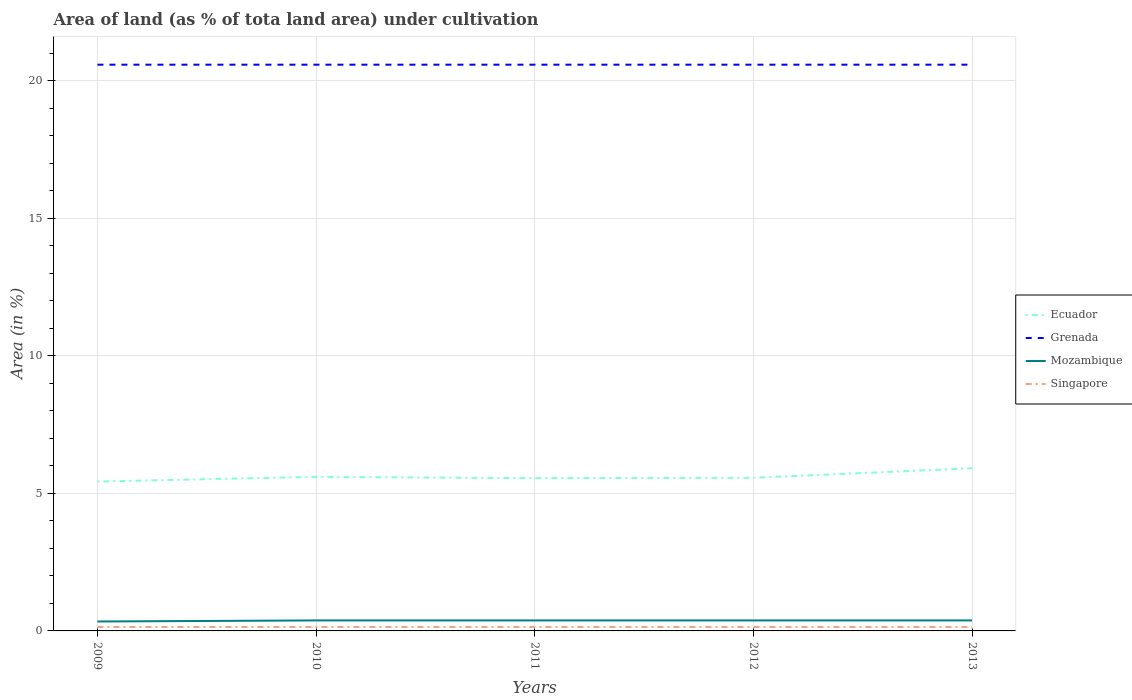How many different coloured lines are there?
Ensure brevity in your answer.  4. Does the line corresponding to Mozambique intersect with the line corresponding to Ecuador?
Offer a very short reply. No. Is the number of lines equal to the number of legend labels?
Your answer should be very brief. Yes. Across all years, what is the maximum percentage of land under cultivation in Grenada?
Offer a terse response. 20.59. What is the difference between the highest and the second highest percentage of land under cultivation in Singapore?
Your response must be concise. 0. What is the difference between the highest and the lowest percentage of land under cultivation in Mozambique?
Keep it short and to the point. 4. How many years are there in the graph?
Your response must be concise. 5. How many legend labels are there?
Keep it short and to the point. 4. What is the title of the graph?
Provide a succinct answer. Area of land (as % of tota land area) under cultivation. Does "Aruba" appear as one of the legend labels in the graph?
Give a very brief answer. No. What is the label or title of the Y-axis?
Your answer should be compact. Area (in %). What is the Area (in %) in Ecuador in 2009?
Your answer should be very brief. 5.43. What is the Area (in %) in Grenada in 2009?
Your answer should be very brief. 20.59. What is the Area (in %) of Mozambique in 2009?
Your answer should be very brief. 0.34. What is the Area (in %) in Singapore in 2009?
Your answer should be compact. 0.14. What is the Area (in %) in Ecuador in 2010?
Your response must be concise. 5.6. What is the Area (in %) of Grenada in 2010?
Make the answer very short. 20.59. What is the Area (in %) in Mozambique in 2010?
Your answer should be very brief. 0.38. What is the Area (in %) in Singapore in 2010?
Your answer should be compact. 0.14. What is the Area (in %) in Ecuador in 2011?
Give a very brief answer. 5.55. What is the Area (in %) in Grenada in 2011?
Your answer should be very brief. 20.59. What is the Area (in %) in Mozambique in 2011?
Offer a terse response. 0.38. What is the Area (in %) in Singapore in 2011?
Offer a terse response. 0.14. What is the Area (in %) in Ecuador in 2012?
Provide a succinct answer. 5.57. What is the Area (in %) of Grenada in 2012?
Offer a terse response. 20.59. What is the Area (in %) in Mozambique in 2012?
Provide a succinct answer. 0.38. What is the Area (in %) of Singapore in 2012?
Keep it short and to the point. 0.14. What is the Area (in %) in Ecuador in 2013?
Provide a succinct answer. 5.91. What is the Area (in %) in Grenada in 2013?
Provide a short and direct response. 20.59. What is the Area (in %) in Mozambique in 2013?
Provide a short and direct response. 0.38. What is the Area (in %) in Singapore in 2013?
Your answer should be very brief. 0.14. Across all years, what is the maximum Area (in %) in Ecuador?
Ensure brevity in your answer.  5.91. Across all years, what is the maximum Area (in %) in Grenada?
Make the answer very short. 20.59. Across all years, what is the maximum Area (in %) in Mozambique?
Your response must be concise. 0.38. Across all years, what is the maximum Area (in %) of Singapore?
Offer a terse response. 0.14. Across all years, what is the minimum Area (in %) in Ecuador?
Give a very brief answer. 5.43. Across all years, what is the minimum Area (in %) in Grenada?
Give a very brief answer. 20.59. Across all years, what is the minimum Area (in %) of Mozambique?
Offer a terse response. 0.34. Across all years, what is the minimum Area (in %) in Singapore?
Your response must be concise. 0.14. What is the total Area (in %) in Ecuador in the graph?
Provide a short and direct response. 28.07. What is the total Area (in %) in Grenada in the graph?
Make the answer very short. 102.94. What is the total Area (in %) in Mozambique in the graph?
Offer a terse response. 1.87. What is the total Area (in %) in Singapore in the graph?
Ensure brevity in your answer.  0.71. What is the difference between the Area (in %) in Ecuador in 2009 and that in 2010?
Ensure brevity in your answer.  -0.17. What is the difference between the Area (in %) in Mozambique in 2009 and that in 2010?
Make the answer very short. -0.04. What is the difference between the Area (in %) in Singapore in 2009 and that in 2010?
Give a very brief answer. 0. What is the difference between the Area (in %) of Ecuador in 2009 and that in 2011?
Your answer should be very brief. -0.12. What is the difference between the Area (in %) in Grenada in 2009 and that in 2011?
Provide a succinct answer. 0. What is the difference between the Area (in %) in Mozambique in 2009 and that in 2011?
Your response must be concise. -0.04. What is the difference between the Area (in %) in Singapore in 2009 and that in 2011?
Your answer should be very brief. 0. What is the difference between the Area (in %) of Ecuador in 2009 and that in 2012?
Make the answer very short. -0.14. What is the difference between the Area (in %) in Mozambique in 2009 and that in 2012?
Provide a short and direct response. -0.04. What is the difference between the Area (in %) of Singapore in 2009 and that in 2012?
Ensure brevity in your answer.  0. What is the difference between the Area (in %) of Ecuador in 2009 and that in 2013?
Offer a terse response. -0.48. What is the difference between the Area (in %) of Mozambique in 2009 and that in 2013?
Provide a short and direct response. -0.04. What is the difference between the Area (in %) of Singapore in 2009 and that in 2013?
Give a very brief answer. 0. What is the difference between the Area (in %) of Ecuador in 2010 and that in 2011?
Your answer should be very brief. 0.05. What is the difference between the Area (in %) in Grenada in 2010 and that in 2011?
Offer a terse response. 0. What is the difference between the Area (in %) in Mozambique in 2010 and that in 2011?
Offer a very short reply. 0. What is the difference between the Area (in %) of Ecuador in 2010 and that in 2012?
Give a very brief answer. 0.03. What is the difference between the Area (in %) of Mozambique in 2010 and that in 2012?
Give a very brief answer. 0. What is the difference between the Area (in %) in Singapore in 2010 and that in 2012?
Your answer should be compact. 0. What is the difference between the Area (in %) of Ecuador in 2010 and that in 2013?
Provide a short and direct response. -0.31. What is the difference between the Area (in %) of Singapore in 2010 and that in 2013?
Your answer should be compact. 0. What is the difference between the Area (in %) of Ecuador in 2011 and that in 2012?
Make the answer very short. -0.01. What is the difference between the Area (in %) in Grenada in 2011 and that in 2012?
Your answer should be compact. 0. What is the difference between the Area (in %) of Ecuador in 2011 and that in 2013?
Offer a very short reply. -0.36. What is the difference between the Area (in %) in Mozambique in 2011 and that in 2013?
Provide a short and direct response. 0. What is the difference between the Area (in %) of Singapore in 2011 and that in 2013?
Offer a very short reply. 0. What is the difference between the Area (in %) of Ecuador in 2012 and that in 2013?
Offer a very short reply. -0.35. What is the difference between the Area (in %) of Grenada in 2012 and that in 2013?
Give a very brief answer. 0. What is the difference between the Area (in %) of Singapore in 2012 and that in 2013?
Provide a short and direct response. 0. What is the difference between the Area (in %) in Ecuador in 2009 and the Area (in %) in Grenada in 2010?
Your response must be concise. -15.16. What is the difference between the Area (in %) in Ecuador in 2009 and the Area (in %) in Mozambique in 2010?
Make the answer very short. 5.05. What is the difference between the Area (in %) of Ecuador in 2009 and the Area (in %) of Singapore in 2010?
Keep it short and to the point. 5.29. What is the difference between the Area (in %) of Grenada in 2009 and the Area (in %) of Mozambique in 2010?
Offer a very short reply. 20.21. What is the difference between the Area (in %) of Grenada in 2009 and the Area (in %) of Singapore in 2010?
Give a very brief answer. 20.45. What is the difference between the Area (in %) in Mozambique in 2009 and the Area (in %) in Singapore in 2010?
Your answer should be very brief. 0.2. What is the difference between the Area (in %) in Ecuador in 2009 and the Area (in %) in Grenada in 2011?
Offer a very short reply. -15.16. What is the difference between the Area (in %) in Ecuador in 2009 and the Area (in %) in Mozambique in 2011?
Keep it short and to the point. 5.05. What is the difference between the Area (in %) in Ecuador in 2009 and the Area (in %) in Singapore in 2011?
Your answer should be very brief. 5.29. What is the difference between the Area (in %) of Grenada in 2009 and the Area (in %) of Mozambique in 2011?
Your answer should be compact. 20.21. What is the difference between the Area (in %) of Grenada in 2009 and the Area (in %) of Singapore in 2011?
Your response must be concise. 20.45. What is the difference between the Area (in %) in Mozambique in 2009 and the Area (in %) in Singapore in 2011?
Provide a succinct answer. 0.2. What is the difference between the Area (in %) of Ecuador in 2009 and the Area (in %) of Grenada in 2012?
Ensure brevity in your answer.  -15.16. What is the difference between the Area (in %) of Ecuador in 2009 and the Area (in %) of Mozambique in 2012?
Give a very brief answer. 5.05. What is the difference between the Area (in %) of Ecuador in 2009 and the Area (in %) of Singapore in 2012?
Your answer should be very brief. 5.29. What is the difference between the Area (in %) in Grenada in 2009 and the Area (in %) in Mozambique in 2012?
Your answer should be compact. 20.21. What is the difference between the Area (in %) in Grenada in 2009 and the Area (in %) in Singapore in 2012?
Provide a short and direct response. 20.45. What is the difference between the Area (in %) of Mozambique in 2009 and the Area (in %) of Singapore in 2012?
Ensure brevity in your answer.  0.2. What is the difference between the Area (in %) in Ecuador in 2009 and the Area (in %) in Grenada in 2013?
Make the answer very short. -15.16. What is the difference between the Area (in %) in Ecuador in 2009 and the Area (in %) in Mozambique in 2013?
Your answer should be very brief. 5.05. What is the difference between the Area (in %) in Ecuador in 2009 and the Area (in %) in Singapore in 2013?
Provide a short and direct response. 5.29. What is the difference between the Area (in %) of Grenada in 2009 and the Area (in %) of Mozambique in 2013?
Provide a succinct answer. 20.21. What is the difference between the Area (in %) in Grenada in 2009 and the Area (in %) in Singapore in 2013?
Provide a short and direct response. 20.45. What is the difference between the Area (in %) in Mozambique in 2009 and the Area (in %) in Singapore in 2013?
Give a very brief answer. 0.2. What is the difference between the Area (in %) of Ecuador in 2010 and the Area (in %) of Grenada in 2011?
Your response must be concise. -14.99. What is the difference between the Area (in %) in Ecuador in 2010 and the Area (in %) in Mozambique in 2011?
Provide a short and direct response. 5.22. What is the difference between the Area (in %) in Ecuador in 2010 and the Area (in %) in Singapore in 2011?
Your answer should be very brief. 5.46. What is the difference between the Area (in %) of Grenada in 2010 and the Area (in %) of Mozambique in 2011?
Offer a very short reply. 20.21. What is the difference between the Area (in %) of Grenada in 2010 and the Area (in %) of Singapore in 2011?
Keep it short and to the point. 20.45. What is the difference between the Area (in %) in Mozambique in 2010 and the Area (in %) in Singapore in 2011?
Make the answer very short. 0.24. What is the difference between the Area (in %) of Ecuador in 2010 and the Area (in %) of Grenada in 2012?
Offer a terse response. -14.99. What is the difference between the Area (in %) in Ecuador in 2010 and the Area (in %) in Mozambique in 2012?
Provide a succinct answer. 5.22. What is the difference between the Area (in %) in Ecuador in 2010 and the Area (in %) in Singapore in 2012?
Provide a succinct answer. 5.46. What is the difference between the Area (in %) of Grenada in 2010 and the Area (in %) of Mozambique in 2012?
Your answer should be very brief. 20.21. What is the difference between the Area (in %) in Grenada in 2010 and the Area (in %) in Singapore in 2012?
Your answer should be very brief. 20.45. What is the difference between the Area (in %) of Mozambique in 2010 and the Area (in %) of Singapore in 2012?
Provide a succinct answer. 0.24. What is the difference between the Area (in %) in Ecuador in 2010 and the Area (in %) in Grenada in 2013?
Keep it short and to the point. -14.99. What is the difference between the Area (in %) of Ecuador in 2010 and the Area (in %) of Mozambique in 2013?
Provide a short and direct response. 5.22. What is the difference between the Area (in %) in Ecuador in 2010 and the Area (in %) in Singapore in 2013?
Make the answer very short. 5.46. What is the difference between the Area (in %) of Grenada in 2010 and the Area (in %) of Mozambique in 2013?
Offer a very short reply. 20.21. What is the difference between the Area (in %) of Grenada in 2010 and the Area (in %) of Singapore in 2013?
Offer a terse response. 20.45. What is the difference between the Area (in %) in Mozambique in 2010 and the Area (in %) in Singapore in 2013?
Make the answer very short. 0.24. What is the difference between the Area (in %) of Ecuador in 2011 and the Area (in %) of Grenada in 2012?
Offer a very short reply. -15.03. What is the difference between the Area (in %) in Ecuador in 2011 and the Area (in %) in Mozambique in 2012?
Offer a very short reply. 5.17. What is the difference between the Area (in %) of Ecuador in 2011 and the Area (in %) of Singapore in 2012?
Ensure brevity in your answer.  5.41. What is the difference between the Area (in %) of Grenada in 2011 and the Area (in %) of Mozambique in 2012?
Give a very brief answer. 20.21. What is the difference between the Area (in %) in Grenada in 2011 and the Area (in %) in Singapore in 2012?
Ensure brevity in your answer.  20.45. What is the difference between the Area (in %) of Mozambique in 2011 and the Area (in %) of Singapore in 2012?
Give a very brief answer. 0.24. What is the difference between the Area (in %) in Ecuador in 2011 and the Area (in %) in Grenada in 2013?
Offer a very short reply. -15.03. What is the difference between the Area (in %) of Ecuador in 2011 and the Area (in %) of Mozambique in 2013?
Offer a terse response. 5.17. What is the difference between the Area (in %) in Ecuador in 2011 and the Area (in %) in Singapore in 2013?
Provide a succinct answer. 5.41. What is the difference between the Area (in %) in Grenada in 2011 and the Area (in %) in Mozambique in 2013?
Ensure brevity in your answer.  20.21. What is the difference between the Area (in %) in Grenada in 2011 and the Area (in %) in Singapore in 2013?
Give a very brief answer. 20.45. What is the difference between the Area (in %) in Mozambique in 2011 and the Area (in %) in Singapore in 2013?
Give a very brief answer. 0.24. What is the difference between the Area (in %) of Ecuador in 2012 and the Area (in %) of Grenada in 2013?
Offer a terse response. -15.02. What is the difference between the Area (in %) of Ecuador in 2012 and the Area (in %) of Mozambique in 2013?
Your answer should be compact. 5.19. What is the difference between the Area (in %) of Ecuador in 2012 and the Area (in %) of Singapore in 2013?
Offer a terse response. 5.43. What is the difference between the Area (in %) of Grenada in 2012 and the Area (in %) of Mozambique in 2013?
Make the answer very short. 20.21. What is the difference between the Area (in %) in Grenada in 2012 and the Area (in %) in Singapore in 2013?
Keep it short and to the point. 20.45. What is the difference between the Area (in %) of Mozambique in 2012 and the Area (in %) of Singapore in 2013?
Your answer should be compact. 0.24. What is the average Area (in %) in Ecuador per year?
Offer a very short reply. 5.61. What is the average Area (in %) of Grenada per year?
Make the answer very short. 20.59. What is the average Area (in %) in Mozambique per year?
Offer a very short reply. 0.37. What is the average Area (in %) in Singapore per year?
Give a very brief answer. 0.14. In the year 2009, what is the difference between the Area (in %) of Ecuador and Area (in %) of Grenada?
Provide a short and direct response. -15.16. In the year 2009, what is the difference between the Area (in %) of Ecuador and Area (in %) of Mozambique?
Keep it short and to the point. 5.09. In the year 2009, what is the difference between the Area (in %) of Ecuador and Area (in %) of Singapore?
Provide a short and direct response. 5.29. In the year 2009, what is the difference between the Area (in %) in Grenada and Area (in %) in Mozambique?
Give a very brief answer. 20.24. In the year 2009, what is the difference between the Area (in %) of Grenada and Area (in %) of Singapore?
Your response must be concise. 20.45. In the year 2009, what is the difference between the Area (in %) of Mozambique and Area (in %) of Singapore?
Make the answer very short. 0.2. In the year 2010, what is the difference between the Area (in %) in Ecuador and Area (in %) in Grenada?
Offer a terse response. -14.99. In the year 2010, what is the difference between the Area (in %) in Ecuador and Area (in %) in Mozambique?
Ensure brevity in your answer.  5.22. In the year 2010, what is the difference between the Area (in %) of Ecuador and Area (in %) of Singapore?
Your response must be concise. 5.46. In the year 2010, what is the difference between the Area (in %) of Grenada and Area (in %) of Mozambique?
Ensure brevity in your answer.  20.21. In the year 2010, what is the difference between the Area (in %) in Grenada and Area (in %) in Singapore?
Make the answer very short. 20.45. In the year 2010, what is the difference between the Area (in %) of Mozambique and Area (in %) of Singapore?
Your answer should be compact. 0.24. In the year 2011, what is the difference between the Area (in %) in Ecuador and Area (in %) in Grenada?
Make the answer very short. -15.03. In the year 2011, what is the difference between the Area (in %) in Ecuador and Area (in %) in Mozambique?
Offer a very short reply. 5.17. In the year 2011, what is the difference between the Area (in %) in Ecuador and Area (in %) in Singapore?
Keep it short and to the point. 5.41. In the year 2011, what is the difference between the Area (in %) of Grenada and Area (in %) of Mozambique?
Your answer should be very brief. 20.21. In the year 2011, what is the difference between the Area (in %) in Grenada and Area (in %) in Singapore?
Give a very brief answer. 20.45. In the year 2011, what is the difference between the Area (in %) in Mozambique and Area (in %) in Singapore?
Make the answer very short. 0.24. In the year 2012, what is the difference between the Area (in %) of Ecuador and Area (in %) of Grenada?
Offer a terse response. -15.02. In the year 2012, what is the difference between the Area (in %) in Ecuador and Area (in %) in Mozambique?
Your answer should be very brief. 5.19. In the year 2012, what is the difference between the Area (in %) of Ecuador and Area (in %) of Singapore?
Provide a short and direct response. 5.43. In the year 2012, what is the difference between the Area (in %) in Grenada and Area (in %) in Mozambique?
Provide a short and direct response. 20.21. In the year 2012, what is the difference between the Area (in %) in Grenada and Area (in %) in Singapore?
Ensure brevity in your answer.  20.45. In the year 2012, what is the difference between the Area (in %) in Mozambique and Area (in %) in Singapore?
Your response must be concise. 0.24. In the year 2013, what is the difference between the Area (in %) of Ecuador and Area (in %) of Grenada?
Provide a succinct answer. -14.67. In the year 2013, what is the difference between the Area (in %) in Ecuador and Area (in %) in Mozambique?
Your response must be concise. 5.53. In the year 2013, what is the difference between the Area (in %) of Ecuador and Area (in %) of Singapore?
Make the answer very short. 5.77. In the year 2013, what is the difference between the Area (in %) of Grenada and Area (in %) of Mozambique?
Offer a very short reply. 20.21. In the year 2013, what is the difference between the Area (in %) of Grenada and Area (in %) of Singapore?
Your answer should be very brief. 20.45. In the year 2013, what is the difference between the Area (in %) in Mozambique and Area (in %) in Singapore?
Give a very brief answer. 0.24. What is the ratio of the Area (in %) of Ecuador in 2009 to that in 2010?
Your response must be concise. 0.97. What is the ratio of the Area (in %) in Grenada in 2009 to that in 2010?
Your response must be concise. 1. What is the ratio of the Area (in %) of Singapore in 2009 to that in 2010?
Ensure brevity in your answer.  1. What is the ratio of the Area (in %) in Ecuador in 2009 to that in 2011?
Offer a very short reply. 0.98. What is the ratio of the Area (in %) in Grenada in 2009 to that in 2011?
Offer a very short reply. 1. What is the ratio of the Area (in %) of Ecuador in 2009 to that in 2012?
Give a very brief answer. 0.98. What is the ratio of the Area (in %) of Grenada in 2009 to that in 2012?
Offer a very short reply. 1. What is the ratio of the Area (in %) of Singapore in 2009 to that in 2012?
Make the answer very short. 1.01. What is the ratio of the Area (in %) in Ecuador in 2009 to that in 2013?
Offer a very short reply. 0.92. What is the ratio of the Area (in %) in Grenada in 2009 to that in 2013?
Offer a very short reply. 1. What is the ratio of the Area (in %) in Mozambique in 2009 to that in 2013?
Your response must be concise. 0.9. What is the ratio of the Area (in %) of Singapore in 2009 to that in 2013?
Provide a short and direct response. 1.01. What is the ratio of the Area (in %) in Ecuador in 2010 to that in 2011?
Give a very brief answer. 1.01. What is the ratio of the Area (in %) in Mozambique in 2010 to that in 2011?
Keep it short and to the point. 1. What is the ratio of the Area (in %) in Singapore in 2010 to that in 2011?
Offer a terse response. 1. What is the ratio of the Area (in %) in Mozambique in 2010 to that in 2012?
Provide a succinct answer. 1. What is the ratio of the Area (in %) in Singapore in 2010 to that in 2012?
Your answer should be compact. 1.01. What is the ratio of the Area (in %) in Ecuador in 2010 to that in 2013?
Give a very brief answer. 0.95. What is the ratio of the Area (in %) of Grenada in 2010 to that in 2013?
Offer a terse response. 1. What is the ratio of the Area (in %) in Singapore in 2010 to that in 2013?
Keep it short and to the point. 1.01. What is the ratio of the Area (in %) in Ecuador in 2011 to that in 2012?
Offer a very short reply. 1. What is the ratio of the Area (in %) of Mozambique in 2011 to that in 2012?
Your answer should be compact. 1. What is the ratio of the Area (in %) of Ecuador in 2011 to that in 2013?
Ensure brevity in your answer.  0.94. What is the ratio of the Area (in %) in Grenada in 2011 to that in 2013?
Your answer should be very brief. 1. What is the ratio of the Area (in %) in Mozambique in 2011 to that in 2013?
Make the answer very short. 1. What is the ratio of the Area (in %) in Ecuador in 2012 to that in 2013?
Provide a short and direct response. 0.94. What is the ratio of the Area (in %) of Singapore in 2012 to that in 2013?
Your answer should be compact. 1. What is the difference between the highest and the second highest Area (in %) in Ecuador?
Your answer should be compact. 0.31. What is the difference between the highest and the second highest Area (in %) of Grenada?
Your answer should be very brief. 0. What is the difference between the highest and the lowest Area (in %) in Ecuador?
Provide a short and direct response. 0.48. What is the difference between the highest and the lowest Area (in %) in Mozambique?
Offer a very short reply. 0.04. What is the difference between the highest and the lowest Area (in %) in Singapore?
Your answer should be compact. 0. 